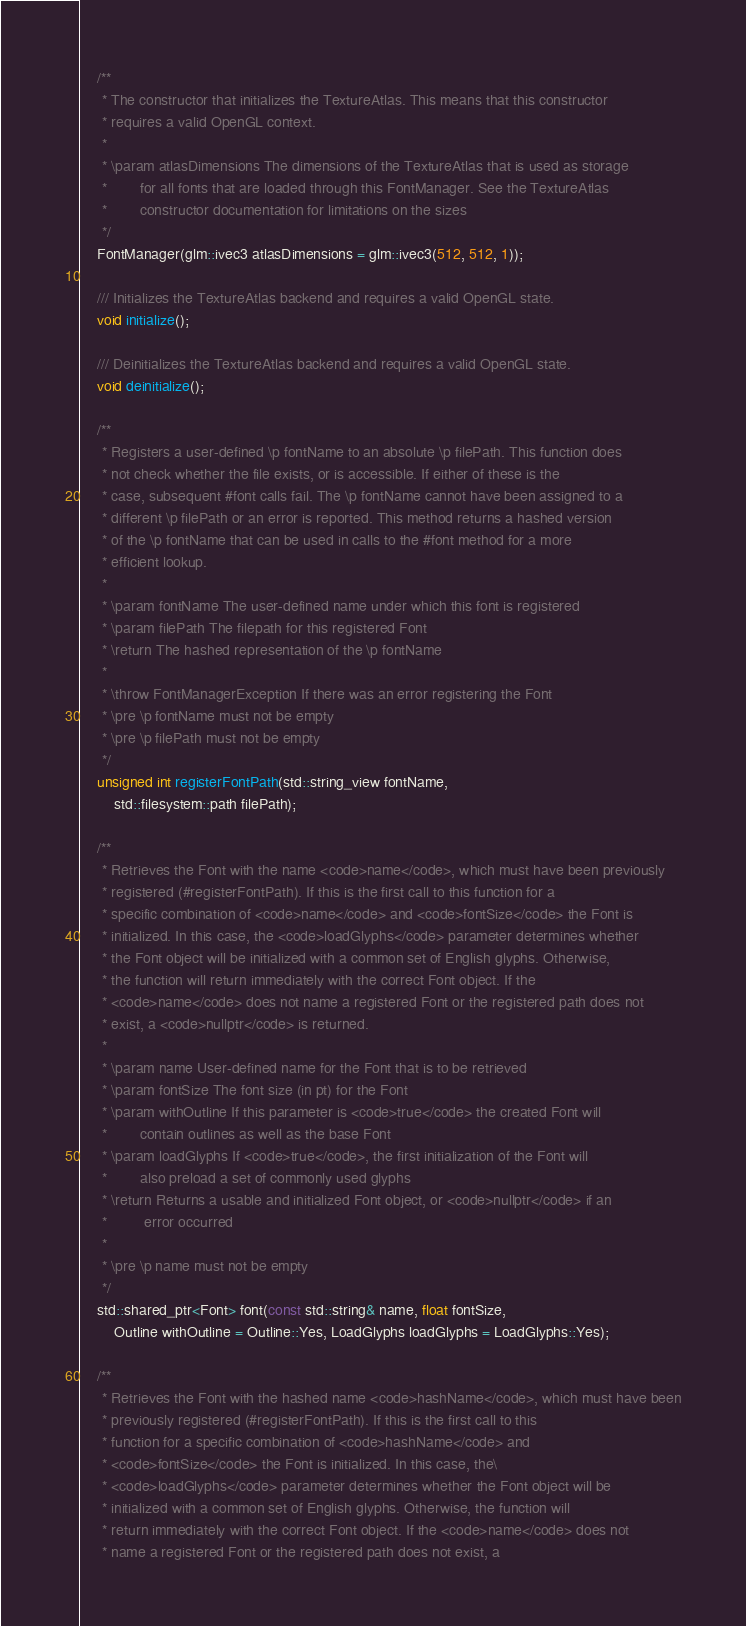Convert code to text. <code><loc_0><loc_0><loc_500><loc_500><_C_>    /**
     * The constructor that initializes the TextureAtlas. This means that this constructor
     * requires a valid OpenGL context.
     *
     * \param atlasDimensions The dimensions of the TextureAtlas that is used as storage
     *        for all fonts that are loaded through this FontManager. See the TextureAtlas
     *        constructor documentation for limitations on the sizes
     */
    FontManager(glm::ivec3 atlasDimensions = glm::ivec3(512, 512, 1));

    /// Initializes the TextureAtlas backend and requires a valid OpenGL state.
    void initialize();

    /// Deinitializes the TextureAtlas backend and requires a valid OpenGL state.
    void deinitialize();

    /**
     * Registers a user-defined \p fontName to an absolute \p filePath. This function does
     * not check whether the file exists, or is accessible. If either of these is the
     * case, subsequent #font calls fail. The \p fontName cannot have been assigned to a
     * different \p filePath or an error is reported. This method returns a hashed version
     * of the \p fontName that can be used in calls to the #font method for a more
     * efficient lookup.
     *
     * \param fontName The user-defined name under which this font is registered
     * \param filePath The filepath for this registered Font
     * \return The hashed representation of the \p fontName
     *
     * \throw FontManagerException If there was an error registering the Font
     * \pre \p fontName must not be empty
     * \pre \p filePath must not be empty
     */
    unsigned int registerFontPath(std::string_view fontName,
        std::filesystem::path filePath);

    /**
     * Retrieves the Font with the name <code>name</code>, which must have been previously
     * registered (#registerFontPath). If this is the first call to this function for a
     * specific combination of <code>name</code> and <code>fontSize</code> the Font is
     * initialized. In this case, the <code>loadGlyphs</code> parameter determines whether
     * the Font object will be initialized with a common set of English glyphs. Otherwise,
     * the function will return immediately with the correct Font object. If the
     * <code>name</code> does not name a registered Font or the registered path does not
     * exist, a <code>nullptr</code> is returned.
     *
     * \param name User-defined name for the Font that is to be retrieved
     * \param fontSize The font size (in pt) for the Font
     * \param withOutline If this parameter is <code>true</code> the created Font will
     *        contain outlines as well as the base Font
     * \param loadGlyphs If <code>true</code>, the first initialization of the Font will
     *        also preload a set of commonly used glyphs
     * \return Returns a usable and initialized Font object, or <code>nullptr</code> if an
     *         error occurred
     *
     * \pre \p name must not be empty
     */
    std::shared_ptr<Font> font(const std::string& name, float fontSize,
        Outline withOutline = Outline::Yes, LoadGlyphs loadGlyphs = LoadGlyphs::Yes);

    /**
     * Retrieves the Font with the hashed name <code>hashName</code>, which must have been
     * previously registered (#registerFontPath). If this is the first call to this
     * function for a specific combination of <code>hashName</code> and
     * <code>fontSize</code> the Font is initialized. In this case, the\
     * <code>loadGlyphs</code> parameter determines whether the Font object will be
     * initialized with a common set of English glyphs. Otherwise, the function will
     * return immediately with the correct Font object. If the <code>name</code> does not
     * name a registered Font or the registered path does not exist, a</code> 